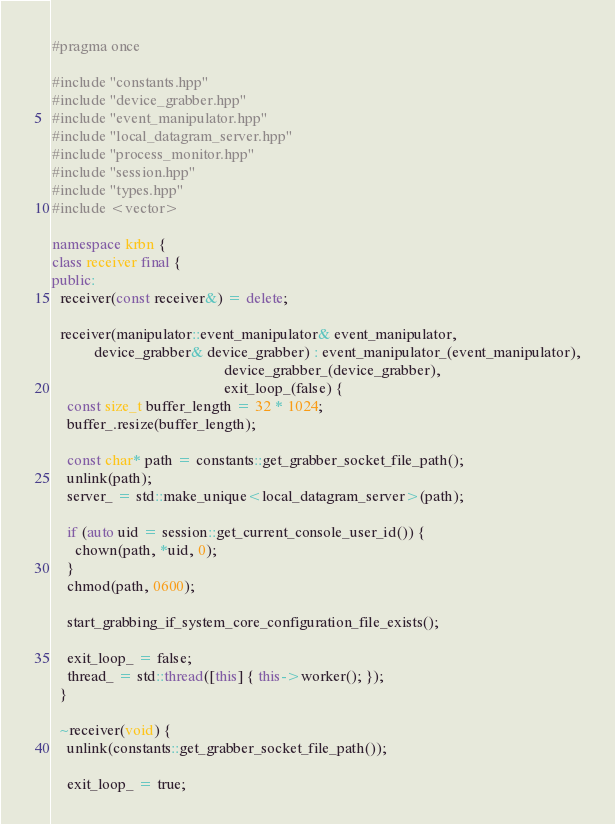<code> <loc_0><loc_0><loc_500><loc_500><_C++_>#pragma once

#include "constants.hpp"
#include "device_grabber.hpp"
#include "event_manipulator.hpp"
#include "local_datagram_server.hpp"
#include "process_monitor.hpp"
#include "session.hpp"
#include "types.hpp"
#include <vector>

namespace krbn {
class receiver final {
public:
  receiver(const receiver&) = delete;

  receiver(manipulator::event_manipulator& event_manipulator,
           device_grabber& device_grabber) : event_manipulator_(event_manipulator),
                                             device_grabber_(device_grabber),
                                             exit_loop_(false) {
    const size_t buffer_length = 32 * 1024;
    buffer_.resize(buffer_length);

    const char* path = constants::get_grabber_socket_file_path();
    unlink(path);
    server_ = std::make_unique<local_datagram_server>(path);

    if (auto uid = session::get_current_console_user_id()) {
      chown(path, *uid, 0);
    }
    chmod(path, 0600);

    start_grabbing_if_system_core_configuration_file_exists();

    exit_loop_ = false;
    thread_ = std::thread([this] { this->worker(); });
  }

  ~receiver(void) {
    unlink(constants::get_grabber_socket_file_path());

    exit_loop_ = true;</code> 